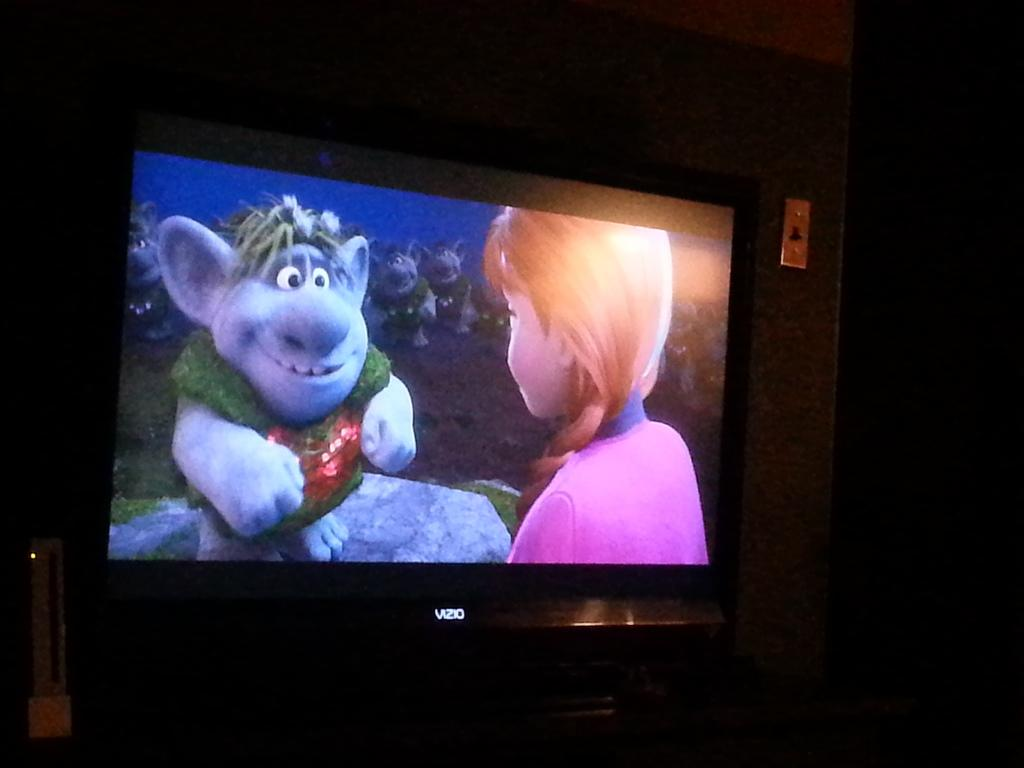Provide a one-sentence caption for the provided image. VIZIO tv playing the movie Frozen in color. 